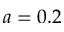Convert formula to latex. <formula><loc_0><loc_0><loc_500><loc_500>a = 0 . 2</formula> 